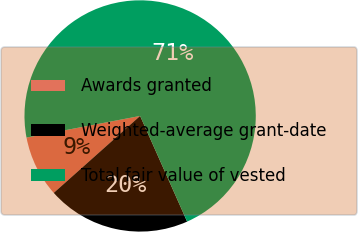Convert chart. <chart><loc_0><loc_0><loc_500><loc_500><pie_chart><fcel>Awards granted<fcel>Weighted-average grant-date<fcel>Total fair value of vested<nl><fcel>8.59%<fcel>20.08%<fcel>71.33%<nl></chart> 